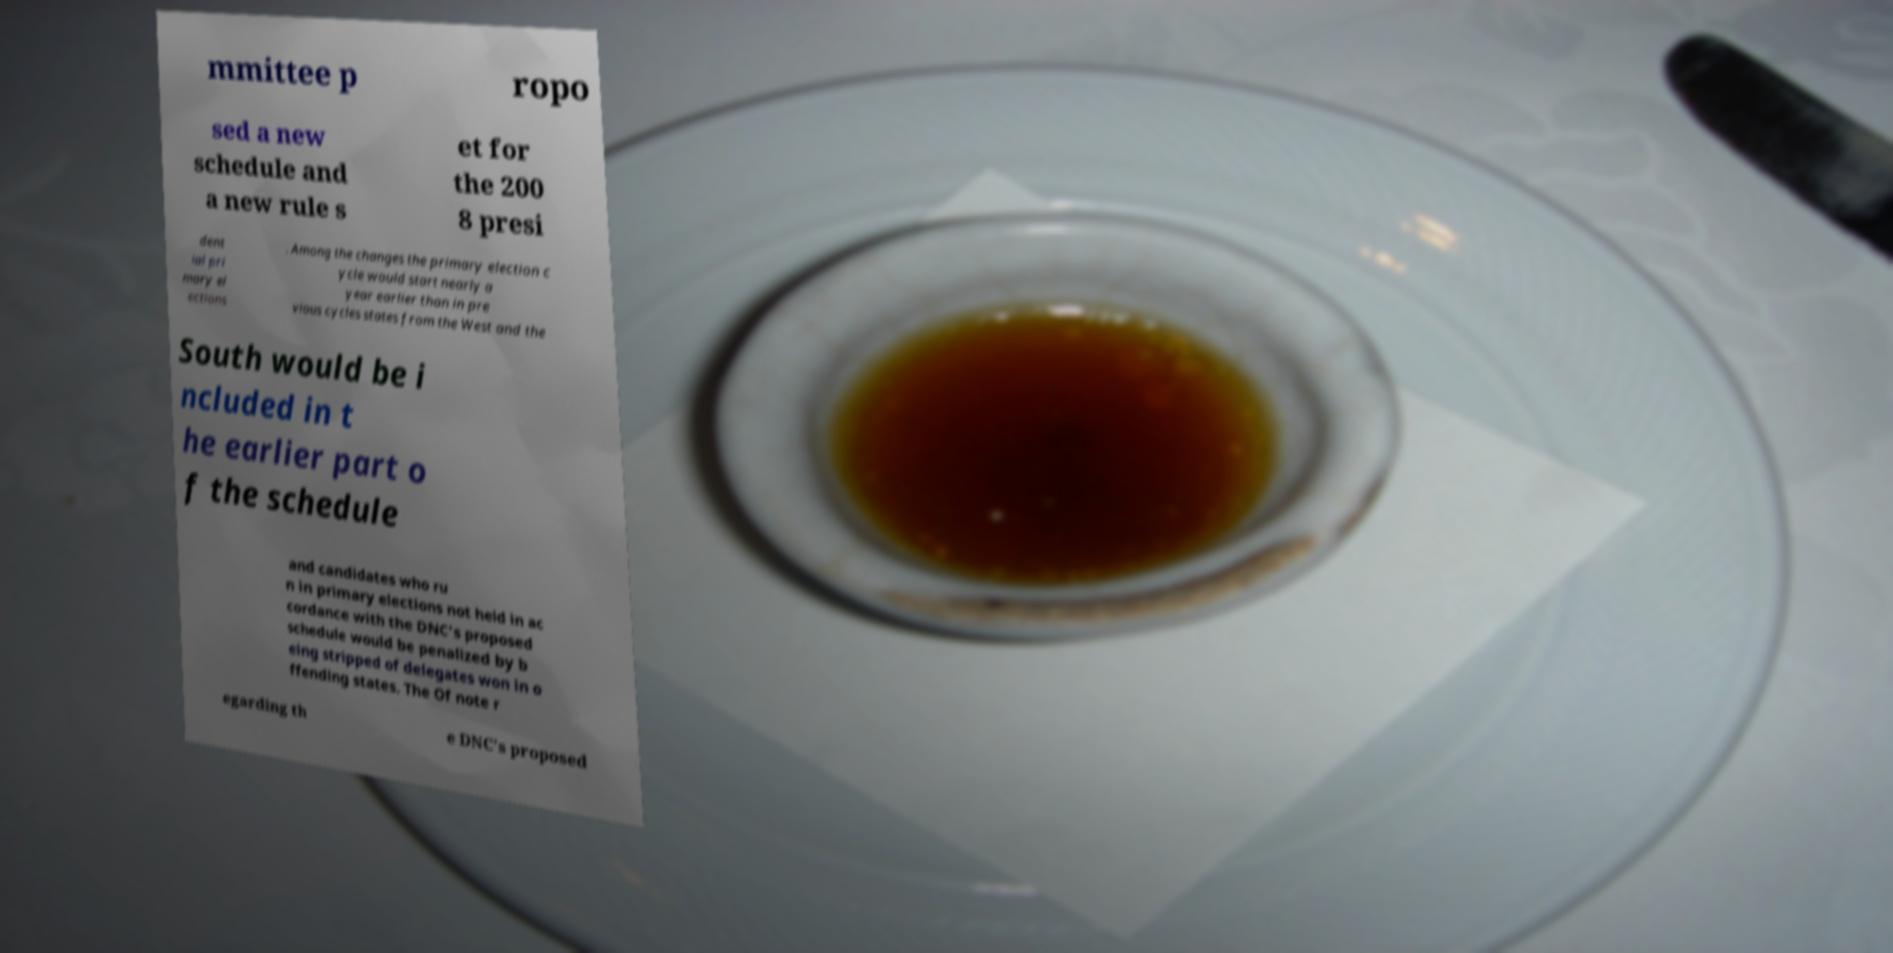Please identify and transcribe the text found in this image. mmittee p ropo sed a new schedule and a new rule s et for the 200 8 presi dent ial pri mary el ections . Among the changes the primary election c ycle would start nearly a year earlier than in pre vious cycles states from the West and the South would be i ncluded in t he earlier part o f the schedule and candidates who ru n in primary elections not held in ac cordance with the DNC's proposed schedule would be penalized by b eing stripped of delegates won in o ffending states. The Of note r egarding th e DNC's proposed 